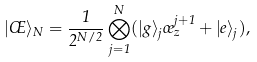Convert formula to latex. <formula><loc_0><loc_0><loc_500><loc_500>| \phi \rangle _ { N } = \frac { 1 } { 2 ^ { N / 2 } } \bigotimes _ { j = 1 } ^ { N } ( | g \rangle _ { j } \sigma _ { z } ^ { j + 1 } + | e \rangle _ { j } ) ,</formula> 